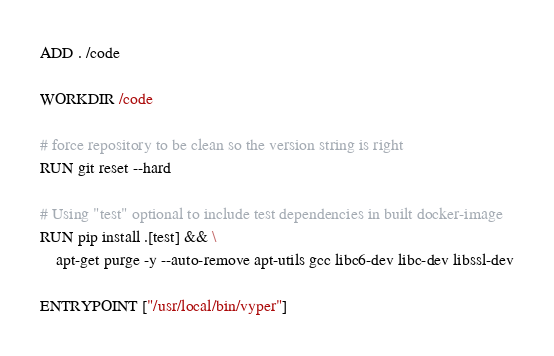Convert code to text. <code><loc_0><loc_0><loc_500><loc_500><_Dockerfile_>
ADD . /code

WORKDIR /code

# force repository to be clean so the version string is right
RUN git reset --hard

# Using "test" optional to include test dependencies in built docker-image
RUN pip install .[test] && \
    apt-get purge -y --auto-remove apt-utils gcc libc6-dev libc-dev libssl-dev

ENTRYPOINT ["/usr/local/bin/vyper"]
</code> 